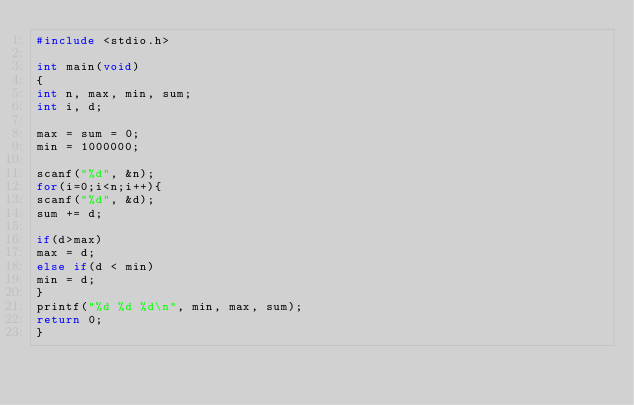Convert code to text. <code><loc_0><loc_0><loc_500><loc_500><_C_>#include <stdio.h>

int main(void)
{
int n, max, min, sum;
int i, d;

max = sum = 0;
min = 1000000;

scanf("%d", &n);
for(i=0;i<n;i++){
scanf("%d", &d);
sum += d;

if(d>max)
max = d;
else if(d < min)
min = d;
}
printf("%d %d %d\n", min, max, sum);
return 0;
}</code> 